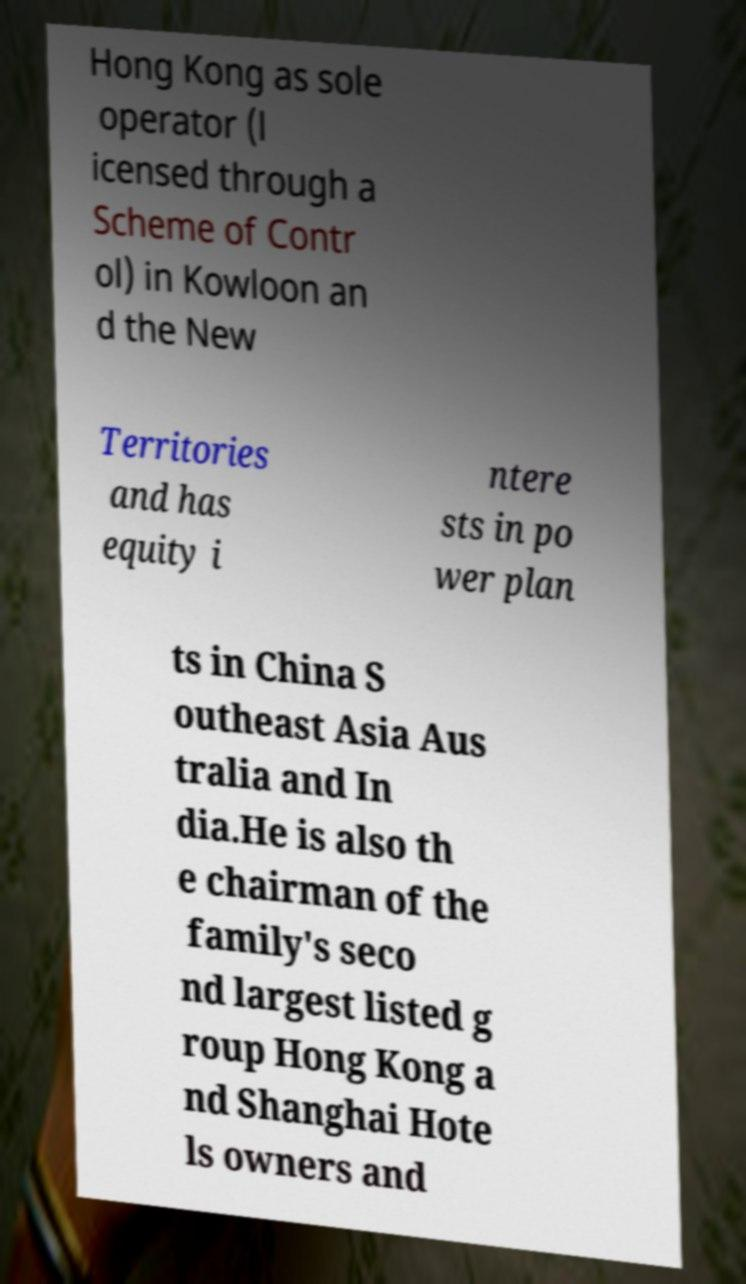Please identify and transcribe the text found in this image. Hong Kong as sole operator (l icensed through a Scheme of Contr ol) in Kowloon an d the New Territories and has equity i ntere sts in po wer plan ts in China S outheast Asia Aus tralia and In dia.He is also th e chairman of the family's seco nd largest listed g roup Hong Kong a nd Shanghai Hote ls owners and 